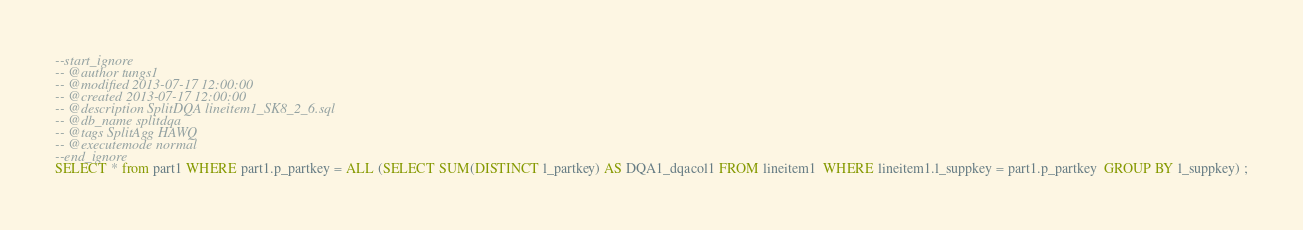Convert code to text. <code><loc_0><loc_0><loc_500><loc_500><_SQL_>--start_ignore
-- @author tungs1
-- @modified 2013-07-17 12:00:00
-- @created 2013-07-17 12:00:00
-- @description SplitDQA lineitem1_SK8_2_6.sql
-- @db_name splitdqa
-- @tags SplitAgg HAWQ
-- @executemode normal
--end_ignore
SELECT * from part1 WHERE part1.p_partkey = ALL (SELECT SUM(DISTINCT l_partkey) AS DQA1_dqacol1 FROM lineitem1  WHERE lineitem1.l_suppkey = part1.p_partkey  GROUP BY l_suppkey) ;
</code> 